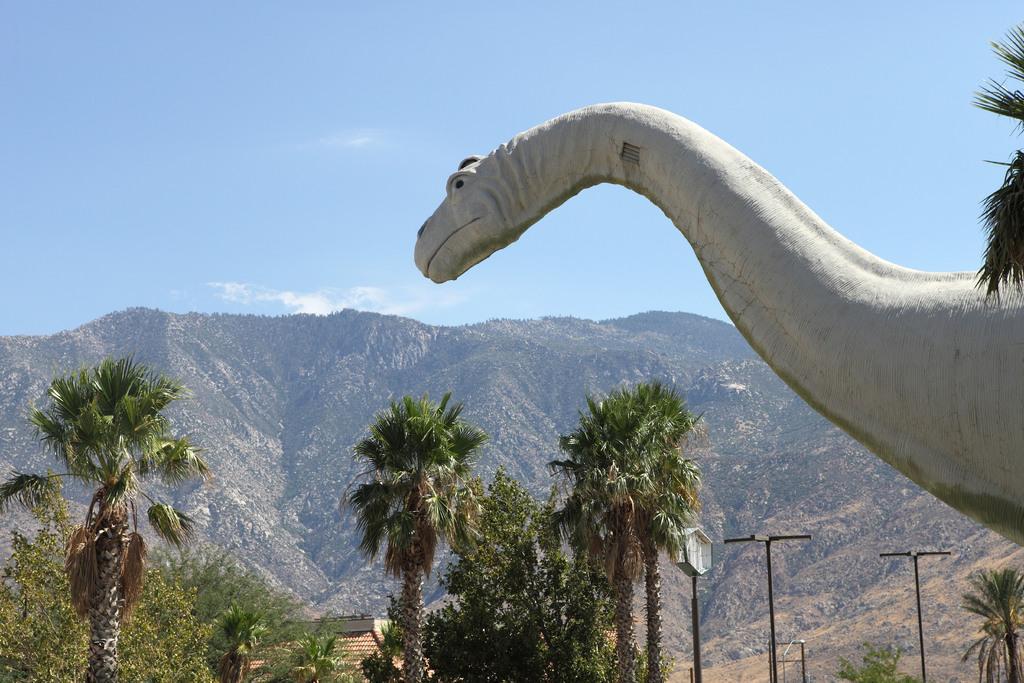How would you summarize this image in a sentence or two? Here in the front we can see a dinosaur statue present over there and we can see trees and plants present all over there and we can see light posts also present here and there and we can see mountains covered with plants and grass all over there and we can see clouds in the sky. 